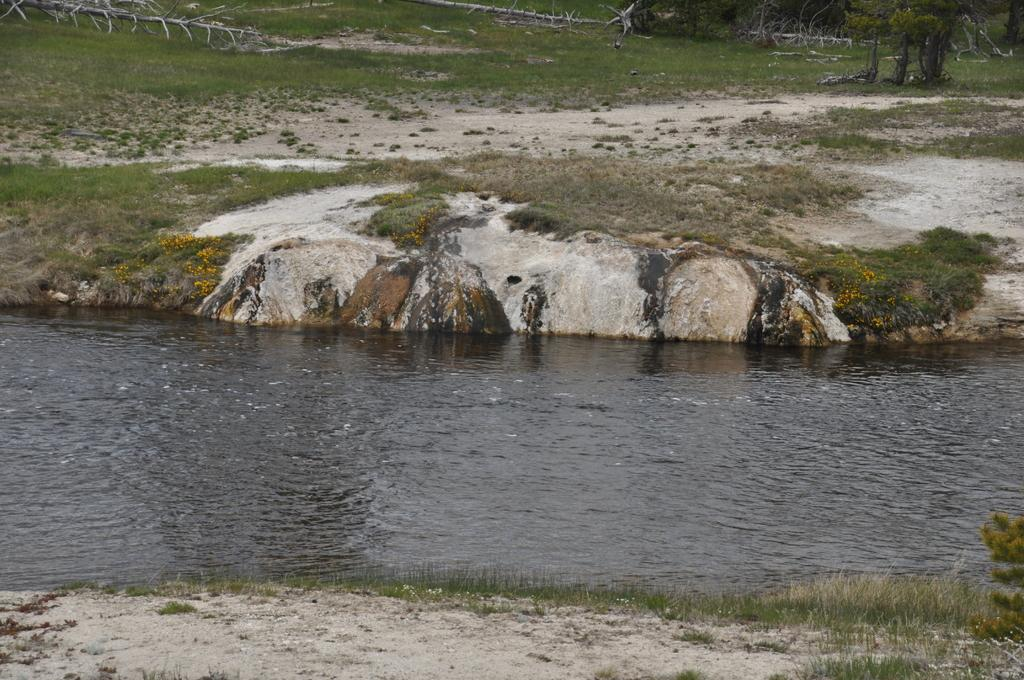What is visible in the foreground of the image? There is a water surface in the foreground of the image. What can be seen in the background of the image? There are trees and grassland in the background of the image. How many books are stacked on the water surface in the image? There are no books present on the water surface in the image. What type of shock can be felt from the water in the image? There is no indication of any shock or electrical current in the water in the image. 